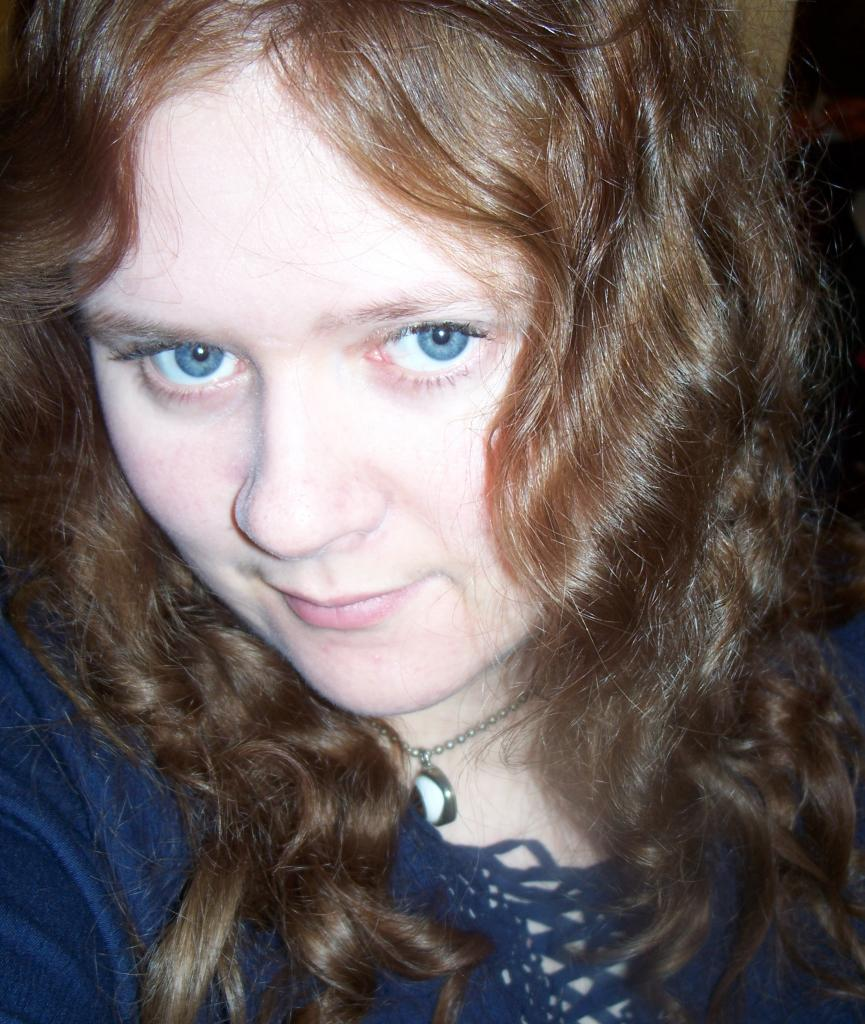Who is present in the image? There is a woman in the image. What expression does the woman have? The woman is smiling. What type of umbrella is the woman holding in the image? There is no umbrella present in the image. What part of the woman's body is mentioned in the image? The provided facts do not mention any specific body parts of the woman. 